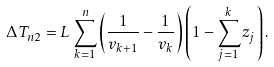<formula> <loc_0><loc_0><loc_500><loc_500>\Delta T _ { n 2 } = L \, \sum _ { k = 1 } ^ { n } \left ( \frac { 1 } { v _ { k + 1 } } - \frac { 1 } { v _ { k } } \right ) \left ( 1 - \sum _ { j = 1 } ^ { k } z _ { j } \right ) .</formula> 